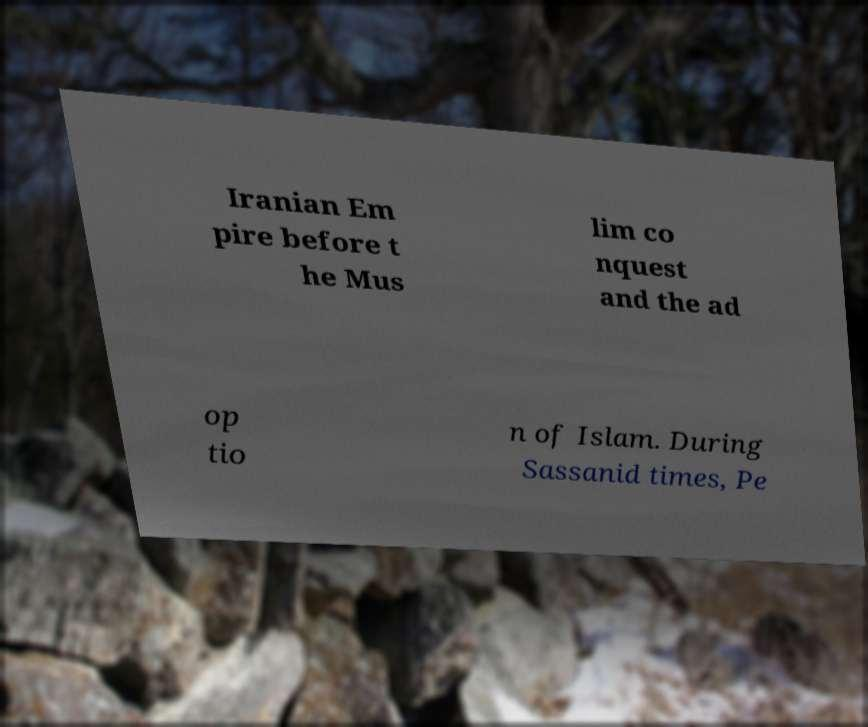I need the written content from this picture converted into text. Can you do that? Iranian Em pire before t he Mus lim co nquest and the ad op tio n of Islam. During Sassanid times, Pe 